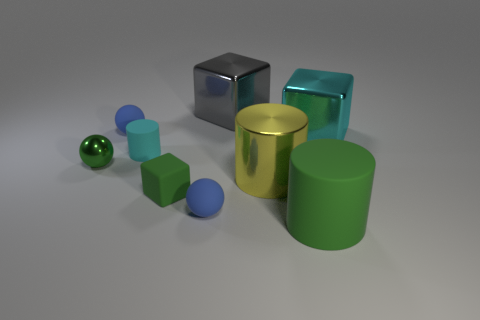Subtract 1 cylinders. How many cylinders are left? 2 Subtract all matte spheres. How many spheres are left? 1 Add 1 small things. How many objects exist? 10 Subtract all balls. How many objects are left? 6 Subtract 0 purple blocks. How many objects are left? 9 Subtract all matte cylinders. Subtract all small cyan matte things. How many objects are left? 6 Add 2 big green cylinders. How many big green cylinders are left? 3 Add 1 big gray metal things. How many big gray metal things exist? 2 